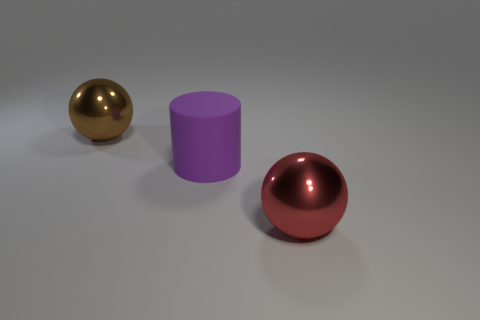How would you describe the lighting in this scene? The lighting in the scene seems uniform and diffuse, with soft shadows indicating a broad light source. The lack of harsh shadows and the smooth illumination on the objects suggest that the light source could be a large softbox or a cloud-covered sky in an outdoor setting, simulating an overcast day where light is scattered. 